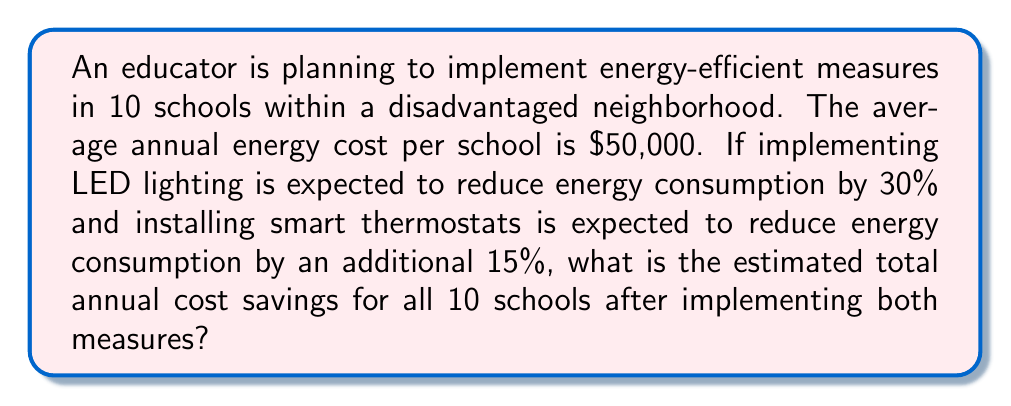Can you solve this math problem? Let's approach this problem step-by-step:

1. Calculate the total annual energy cost for all 10 schools:
   $$\text{Total annual cost} = 10 \times \$50,000 = \$500,000$$

2. Calculate the savings from LED lighting (30% reduction):
   $$\text{LED savings} = 30\% \times \$500,000 = 0.30 \times \$500,000 = \$150,000$$

3. Calculate the remaining energy cost after LED implementation:
   $$\text{Remaining cost} = \$500,000 - \$150,000 = \$350,000$$

4. Calculate the additional savings from smart thermostats (15% of the remaining cost):
   $$\text{Thermostat savings} = 15\% \times \$350,000 = 0.15 \times \$350,000 = \$52,500$$

5. Calculate the total savings by adding the savings from both measures:
   $$\text{Total savings} = \text{LED savings} + \text{Thermostat savings}$$
   $$\text{Total savings} = \$150,000 + \$52,500 = \$202,500$$

Therefore, the estimated total annual cost savings for all 10 schools after implementing both energy-efficient measures is $202,500.
Answer: $202,500 